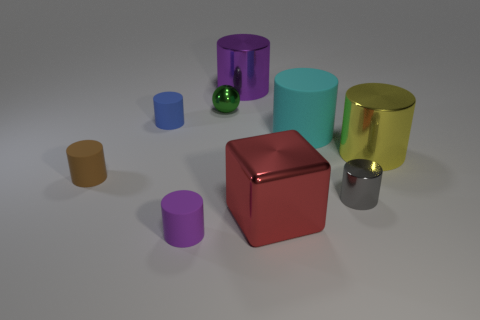There is a purple metallic thing that is the same shape as the large cyan rubber thing; what is its size?
Your answer should be compact. Large. What shape is the tiny green metallic thing?
Ensure brevity in your answer.  Sphere. Does the tiny brown cylinder have the same material as the ball that is on the right side of the tiny blue matte cylinder?
Provide a short and direct response. No. How many matte objects are either tiny gray cylinders or big things?
Your response must be concise. 1. What size is the purple thing in front of the tiny brown rubber cylinder?
Keep it short and to the point. Small. The ball that is made of the same material as the yellow object is what size?
Make the answer very short. Small. How many other big blocks have the same color as the block?
Keep it short and to the point. 0. Are there any big red objects?
Provide a succinct answer. Yes. There is a small purple matte thing; does it have the same shape as the purple thing behind the tiny gray thing?
Keep it short and to the point. Yes. The big metal cylinder that is behind the matte thing on the right side of the purple thing in front of the tiny brown matte object is what color?
Your response must be concise. Purple. 